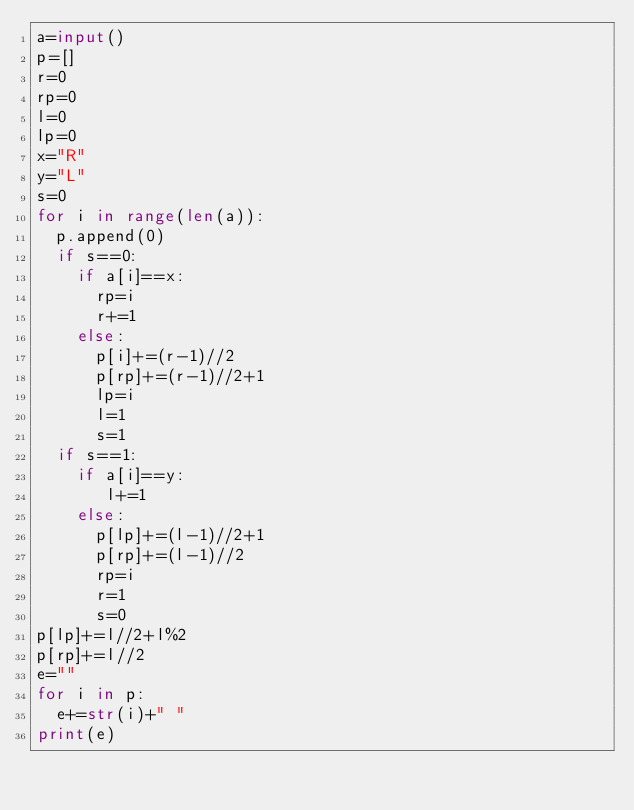<code> <loc_0><loc_0><loc_500><loc_500><_Python_>a=input()
p=[]
r=0
rp=0
l=0
lp=0
x="R"
y="L"
s=0
for i in range(len(a)):
  p.append(0)
  if s==0:
    if a[i]==x:
      rp=i
      r+=1
    else:
      p[i]+=(r-1)//2
      p[rp]+=(r-1)//2+1
      lp=i
      l=1
      s=1
  if s==1:
    if a[i]==y:
       l+=1
    else:
      p[lp]+=(l-1)//2+1
      p[rp]+=(l-1)//2
      rp=i
      r=1
      s=0
p[lp]+=l//2+l%2
p[rp]+=l//2
e=""
for i in p:
  e+=str(i)+" "
print(e)</code> 